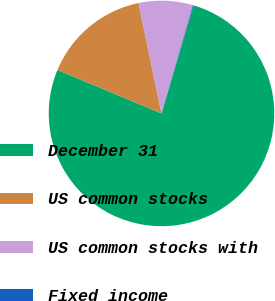Convert chart. <chart><loc_0><loc_0><loc_500><loc_500><pie_chart><fcel>December 31<fcel>US common stocks<fcel>US common stocks with<fcel>Fixed income<nl><fcel>76.68%<fcel>15.43%<fcel>7.77%<fcel>0.11%<nl></chart> 